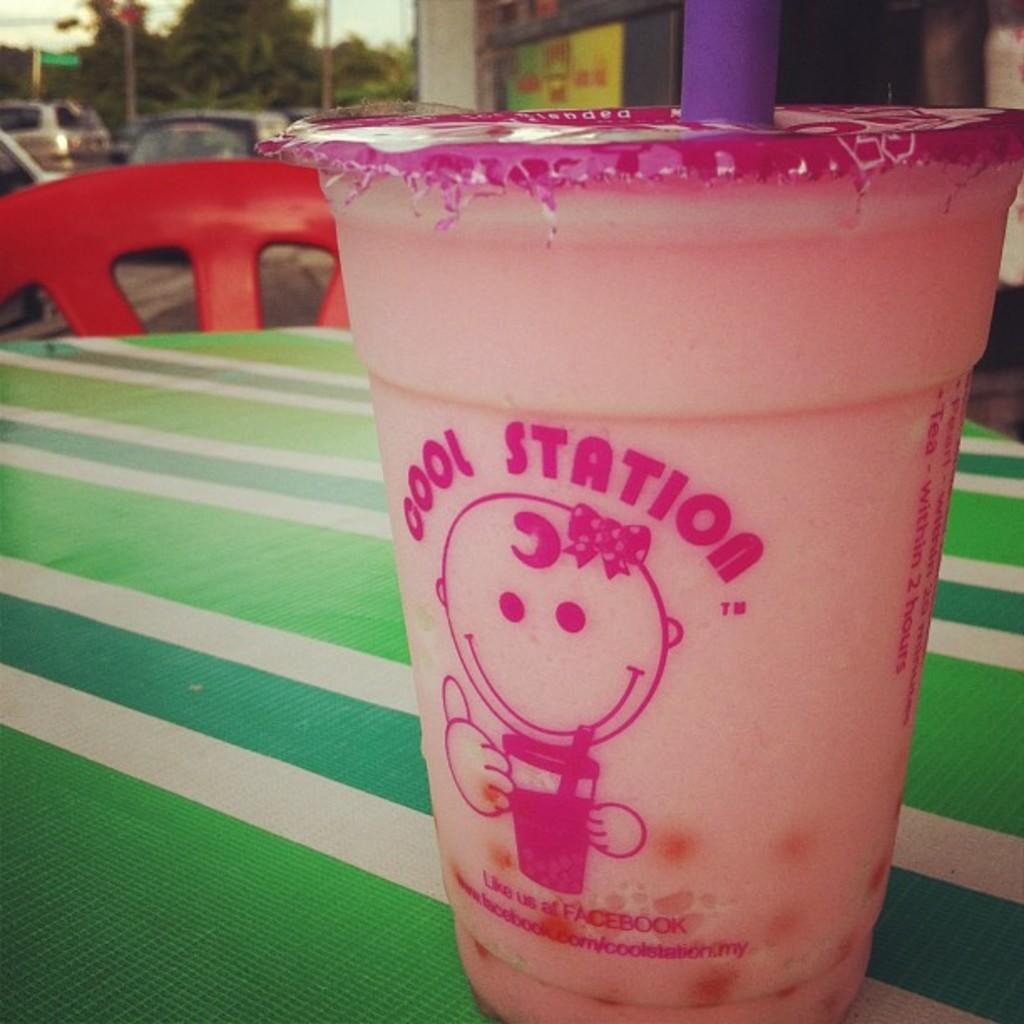What is on the table in the image? There is a coffee cup on a table in the image. What else can be seen in the image besides the coffee cup? Cars and a building are visible in the image. What type of breath can be seen coming from the coffee cup in the image? There is no breath visible in the image, as the coffee cup is an inanimate object. 